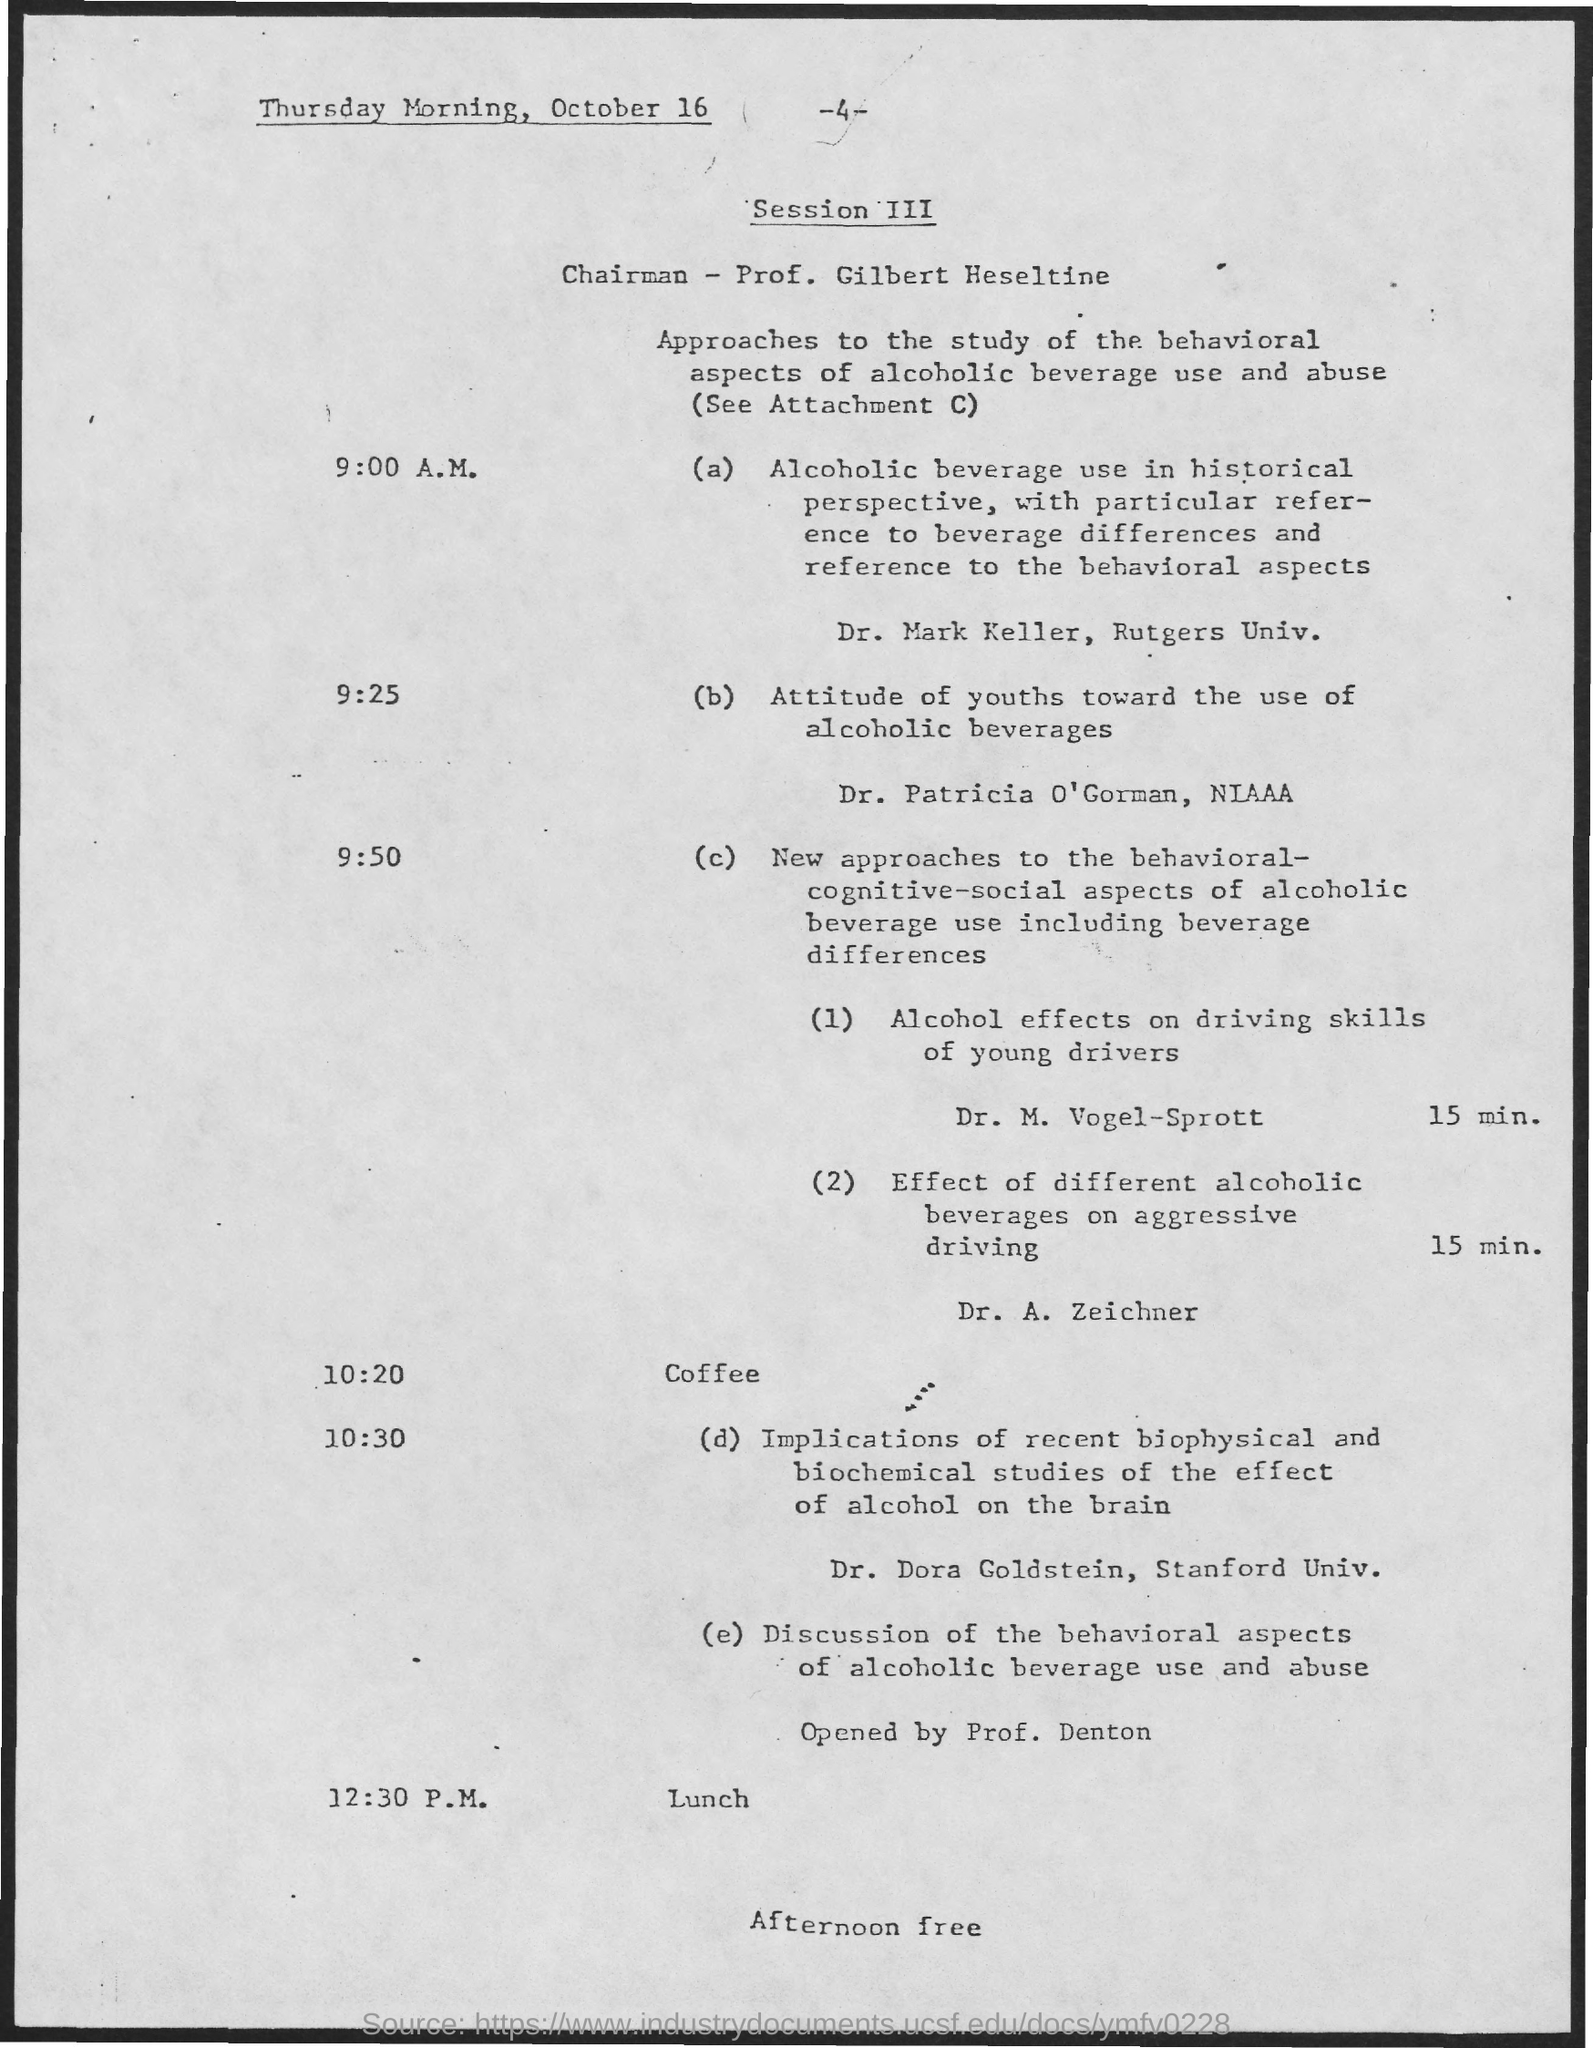What is the schedule at the time of 12:30 pm as mentioned in the given page ?
Give a very brief answer. Lunch. What is the name of the chairman as mentioned in the given page ?
Make the answer very short. Prof. Gilbert Heseltine. What is the schedule at the time of 10:20 as mentioned in the given page ?
Provide a succinct answer. Coffee. 